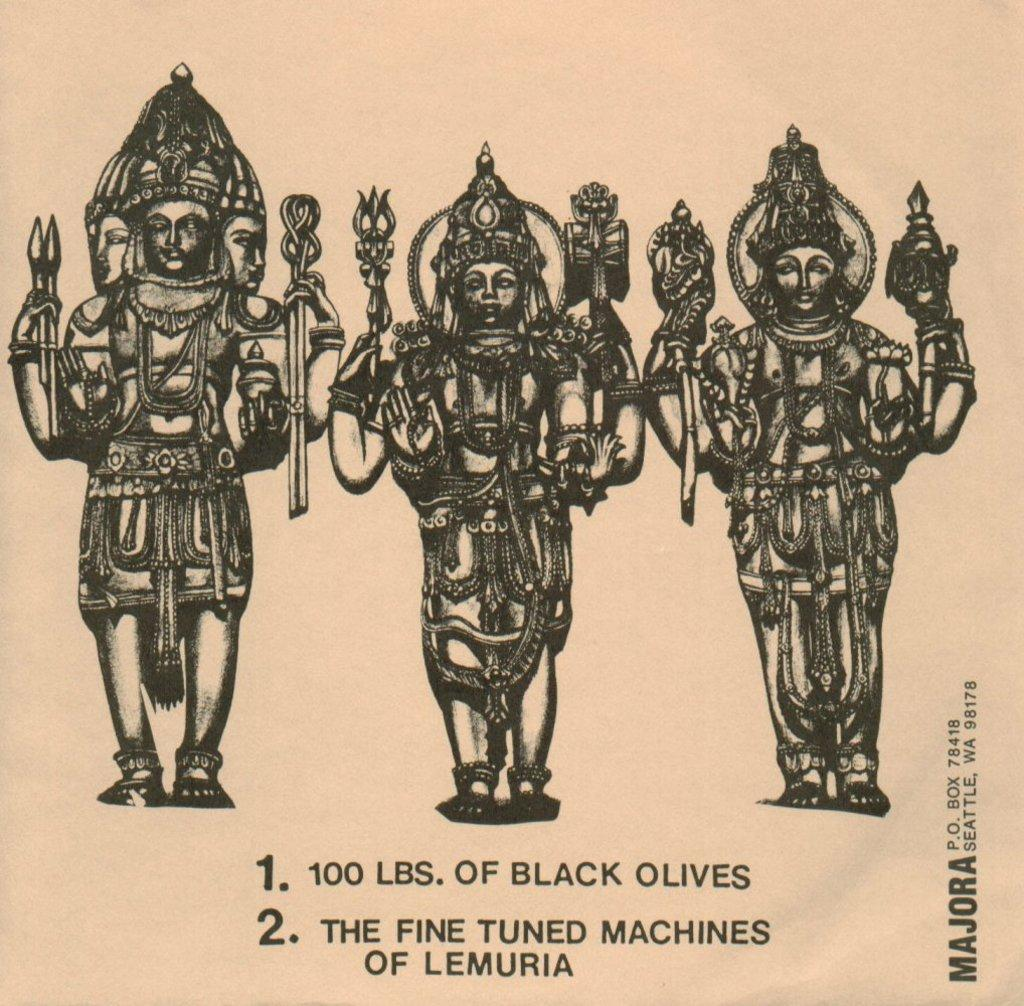What is depicted in the sketches in the image? There are sketches of an idol in the image. What material are the sketches printed on? The sketches are printed on paper. What additional information can be found at the bottom of the image? There is text at the bottom of the image. What type of leg is visible in the image? There is no leg visible in the image; it features sketches of an idol and text on paper. What kind of board is being used for the dinner in the image? There is no dinner or board present in the image. 